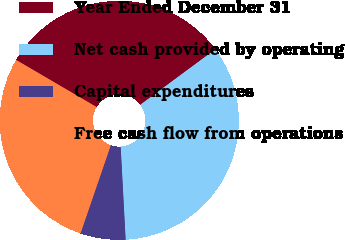Convert chart to OTSL. <chart><loc_0><loc_0><loc_500><loc_500><pie_chart><fcel>Year Ended December 31<fcel>Net cash provided by operating<fcel>Capital expenditures<fcel>Free cash flow from operations<nl><fcel>31.44%<fcel>34.28%<fcel>6.11%<fcel>28.17%<nl></chart> 